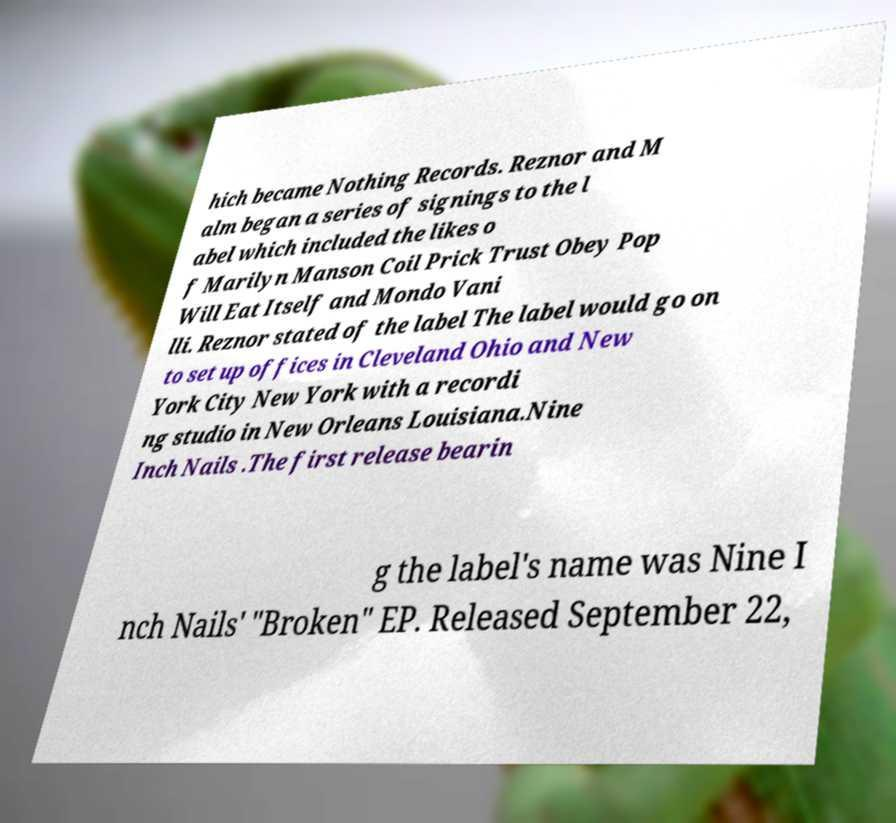What messages or text are displayed in this image? I need them in a readable, typed format. hich became Nothing Records. Reznor and M alm began a series of signings to the l abel which included the likes o f Marilyn Manson Coil Prick Trust Obey Pop Will Eat Itself and Mondo Vani lli. Reznor stated of the label The label would go on to set up offices in Cleveland Ohio and New York City New York with a recordi ng studio in New Orleans Louisiana.Nine Inch Nails .The first release bearin g the label's name was Nine I nch Nails' "Broken" EP. Released September 22, 